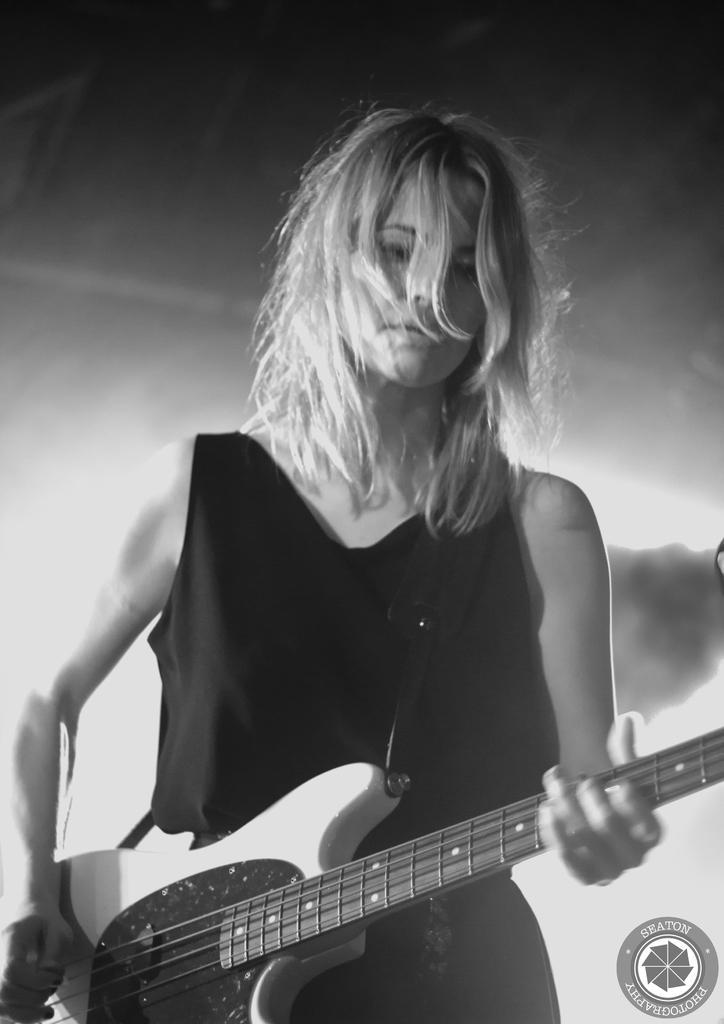Can you describe this image briefly? Here we can see a woman playing a guitar present in her hand and she is wearing a black dress 